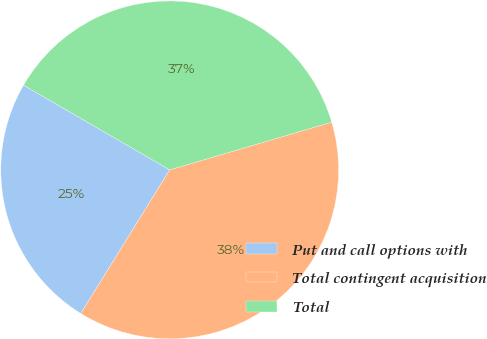Convert chart to OTSL. <chart><loc_0><loc_0><loc_500><loc_500><pie_chart><fcel>Put and call options with<fcel>Total contingent acquisition<fcel>Total<nl><fcel>24.54%<fcel>38.38%<fcel>37.08%<nl></chart> 